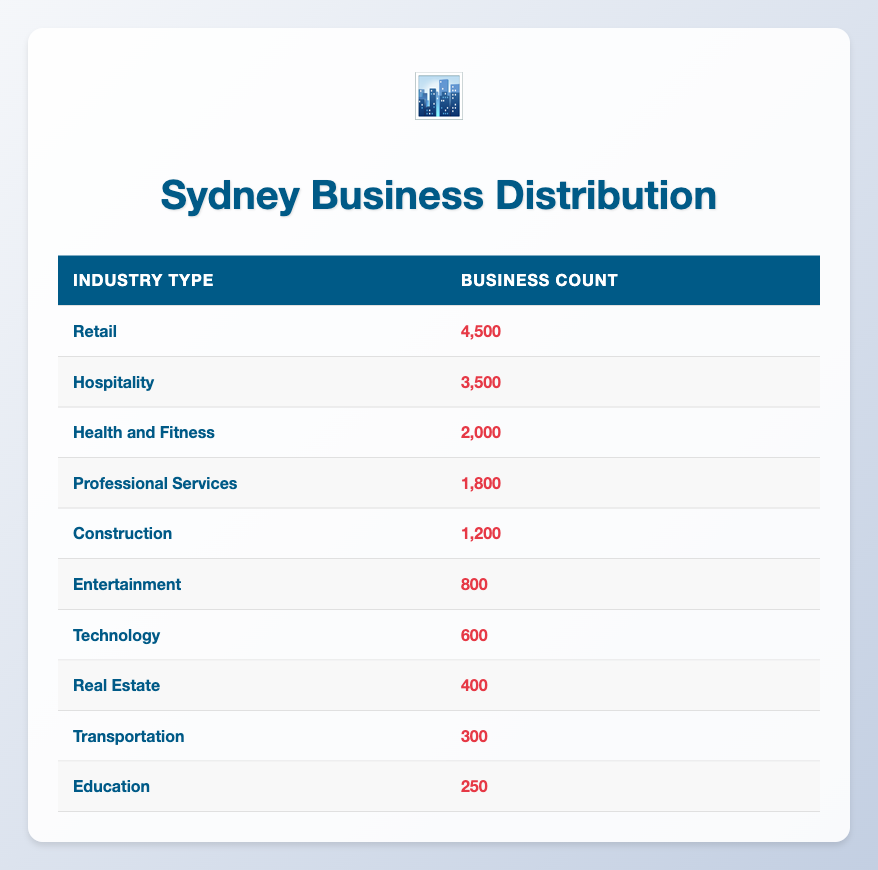What is the total number of businesses in the Retail industry? The table indicates that there are 4,500 businesses in the Retail industry listed under Business Count.
Answer: 4,500 Which industry has more businesses: Hospitality or Health and Fitness? Hospitality has 3,500 businesses while Health and Fitness has 2,000. Since 3,500 is greater than 2,000, Hospitality has more businesses.
Answer: Hospitality What is the combined number of businesses in Professional Services and Construction? Professional Services has 1,800 businesses and Construction has 1,200. When combined: 1,800 + 1,200 = 3,000.
Answer: 3,000 Is the number of Entertainment businesses greater than the number of Technology businesses? The Entertainment industry has 800 businesses and Technology has 600. Since 800 is greater than 600, the statement is true.
Answer: Yes What percentage of the total businesses belong to the Retail industry? First, calculate the total number of businesses by adding all the business counts: 4,500 + 3,500 + 2,000 + 1,800 + 1,200 + 800 + 600 + 400 + 300 + 250 = 16,350. Then, find the percentage of Retail: (4,500 / 16,350) * 100 = 27.5%.
Answer: 27.5% What is the difference in the number of businesses between Health and Fitness and Transportation? Health and Fitness has 2,000 businesses while Transportation has 300. The difference is 2,000 - 300 = 1,700.
Answer: 1,700 Does the Real Estate industry have more businesses than the Education industry? Real Estate has 400 businesses while Education has 250. Since 400 is greater than 250, Real Estate has more businesses.
Answer: Yes What is the average number of businesses per industry, based on the data provided? There are 10 industries listed. The total number of businesses is 16,350. To find the average: 16,350 / 10 = 1,635.
Answer: 1,635 How many industries have a business count less than 1,000? The industries with less than 1,000 businesses are Technology (600), Real Estate (400), Transportation (300), and Education (250). That totals four industries.
Answer: 4 